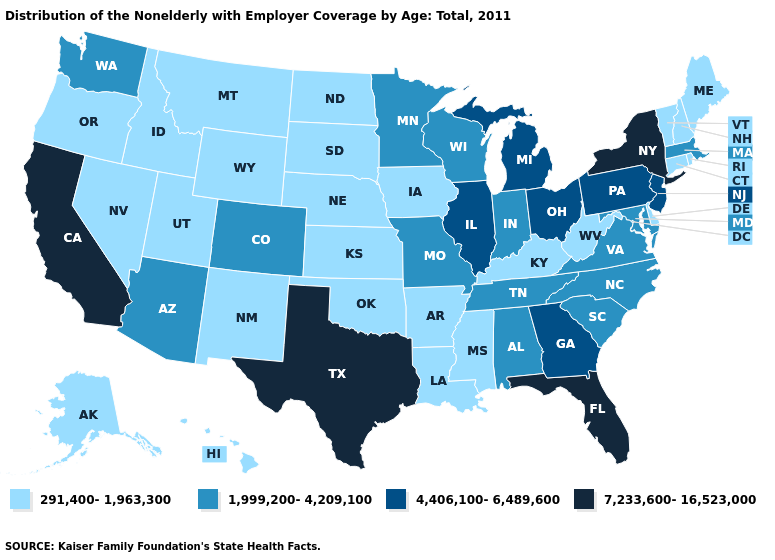Among the states that border Rhode Island , which have the lowest value?
Write a very short answer. Connecticut. What is the value of Tennessee?
Write a very short answer. 1,999,200-4,209,100. What is the value of Wisconsin?
Quick response, please. 1,999,200-4,209,100. Name the states that have a value in the range 1,999,200-4,209,100?
Keep it brief. Alabama, Arizona, Colorado, Indiana, Maryland, Massachusetts, Minnesota, Missouri, North Carolina, South Carolina, Tennessee, Virginia, Washington, Wisconsin. What is the lowest value in the Northeast?
Concise answer only. 291,400-1,963,300. Does Texas have the highest value in the South?
Give a very brief answer. Yes. Among the states that border Nebraska , does Colorado have the highest value?
Short answer required. Yes. Name the states that have a value in the range 4,406,100-6,489,600?
Write a very short answer. Georgia, Illinois, Michigan, New Jersey, Ohio, Pennsylvania. Name the states that have a value in the range 1,999,200-4,209,100?
Quick response, please. Alabama, Arizona, Colorado, Indiana, Maryland, Massachusetts, Minnesota, Missouri, North Carolina, South Carolina, Tennessee, Virginia, Washington, Wisconsin. Which states have the highest value in the USA?
Keep it brief. California, Florida, New York, Texas. Which states have the highest value in the USA?
Short answer required. California, Florida, New York, Texas. What is the value of Kentucky?
Be succinct. 291,400-1,963,300. Is the legend a continuous bar?
Write a very short answer. No. What is the value of Nevada?
Write a very short answer. 291,400-1,963,300. 